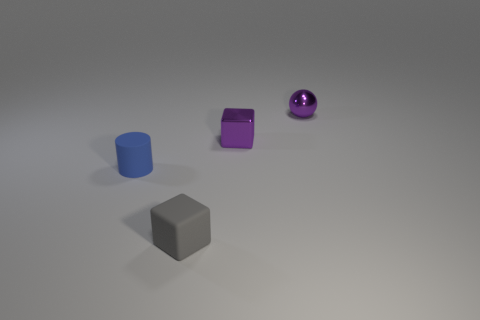The other object that is the same shape as the tiny gray thing is what size?
Offer a very short reply. Small. There is a tiny purple object right of the small purple object that is to the left of the small purple ball; what number of blue matte cylinders are right of it?
Offer a very short reply. 0. What number of spheres are tiny cyan rubber objects or rubber objects?
Offer a terse response. 0. What is the color of the small matte object that is behind the cube left of the tiny shiny object in front of the small sphere?
Offer a terse response. Blue. How many other things are there of the same size as the ball?
Your answer should be compact. 3. Are there any other things that are the same shape as the blue rubber object?
Your answer should be very brief. No. The other thing that is made of the same material as the small blue thing is what color?
Your response must be concise. Gray. Are there an equal number of gray things behind the purple ball and small matte cylinders?
Offer a very short reply. No. There is a rubber cube that is the same size as the purple metal sphere; what color is it?
Provide a succinct answer. Gray. There is a small purple metallic thing behind the tiny purple metallic thing in front of the ball; is there a small gray rubber object in front of it?
Your response must be concise. Yes. 